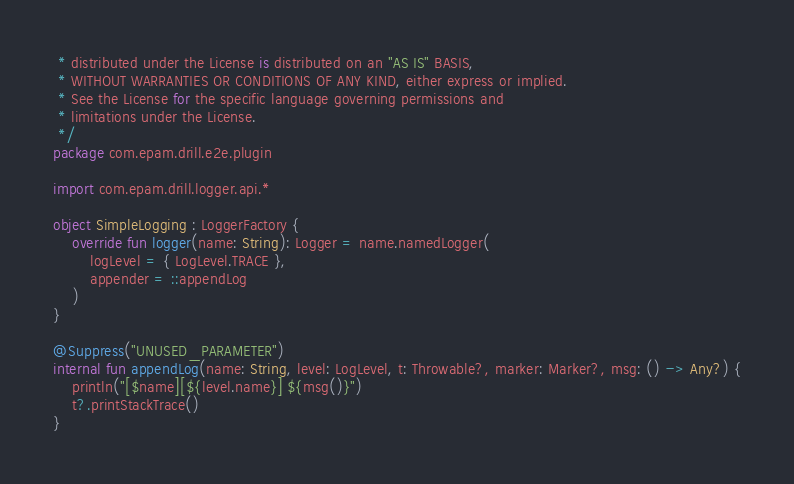<code> <loc_0><loc_0><loc_500><loc_500><_Kotlin_> * distributed under the License is distributed on an "AS IS" BASIS,
 * WITHOUT WARRANTIES OR CONDITIONS OF ANY KIND, either express or implied.
 * See the License for the specific language governing permissions and
 * limitations under the License.
 */
package com.epam.drill.e2e.plugin

import com.epam.drill.logger.api.*

object SimpleLogging : LoggerFactory {
    override fun logger(name: String): Logger = name.namedLogger(
        logLevel = { LogLevel.TRACE },
        appender = ::appendLog
    )
}

@Suppress("UNUSED_PARAMETER")
internal fun appendLog(name: String, level: LogLevel, t: Throwable?, marker: Marker?, msg: () -> Any?) {
    println("[$name][${level.name}] ${msg()}")
    t?.printStackTrace()
}
</code> 